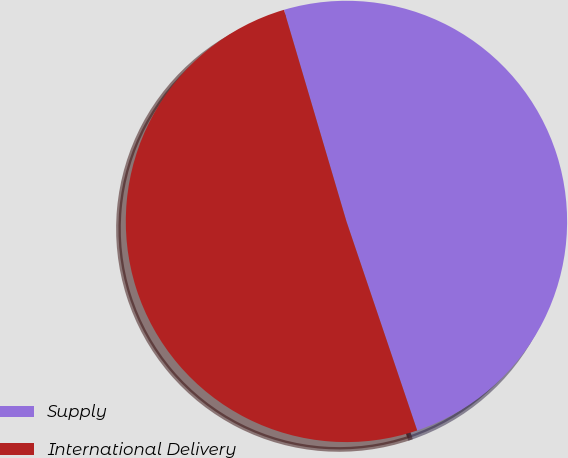Convert chart. <chart><loc_0><loc_0><loc_500><loc_500><pie_chart><fcel>Supply<fcel>International Delivery<nl><fcel>49.38%<fcel>50.62%<nl></chart> 